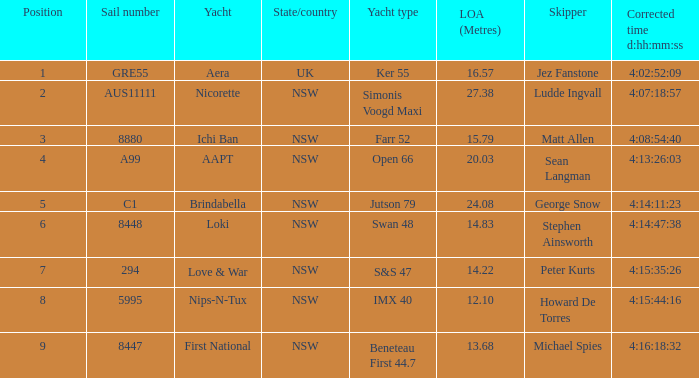What is the ranking for NSW open 66 racing boat.  4.0. Could you parse the entire table? {'header': ['Position', 'Sail number', 'Yacht', 'State/country', 'Yacht type', 'LOA (Metres)', 'Skipper', 'Corrected time d:hh:mm:ss'], 'rows': [['1', 'GRE55', 'Aera', 'UK', 'Ker 55', '16.57', 'Jez Fanstone', '4:02:52:09'], ['2', 'AUS11111', 'Nicorette', 'NSW', 'Simonis Voogd Maxi', '27.38', 'Ludde Ingvall', '4:07:18:57'], ['3', '8880', 'Ichi Ban', 'NSW', 'Farr 52', '15.79', 'Matt Allen', '4:08:54:40'], ['4', 'A99', 'AAPT', 'NSW', 'Open 66', '20.03', 'Sean Langman', '4:13:26:03'], ['5', 'C1', 'Brindabella', 'NSW', 'Jutson 79', '24.08', 'George Snow', '4:14:11:23'], ['6', '8448', 'Loki', 'NSW', 'Swan 48', '14.83', 'Stephen Ainsworth', '4:14:47:38'], ['7', '294', 'Love & War', 'NSW', 'S&S 47', '14.22', 'Peter Kurts', '4:15:35:26'], ['8', '5995', 'Nips-N-Tux', 'NSW', 'IMX 40', '12.10', 'Howard De Torres', '4:15:44:16'], ['9', '8447', 'First National', 'NSW', 'Beneteau First 44.7', '13.68', 'Michael Spies', '4:16:18:32']]} 